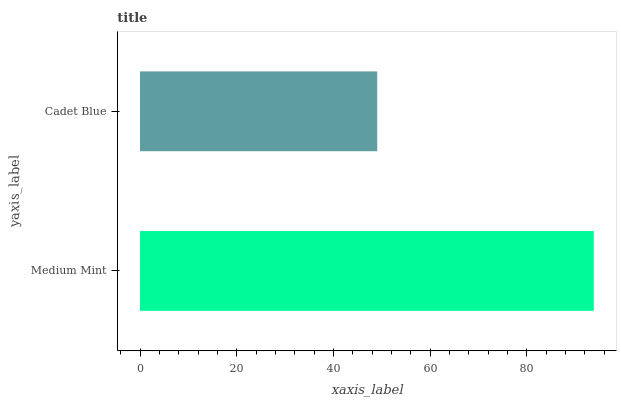Is Cadet Blue the minimum?
Answer yes or no. Yes. Is Medium Mint the maximum?
Answer yes or no. Yes. Is Cadet Blue the maximum?
Answer yes or no. No. Is Medium Mint greater than Cadet Blue?
Answer yes or no. Yes. Is Cadet Blue less than Medium Mint?
Answer yes or no. Yes. Is Cadet Blue greater than Medium Mint?
Answer yes or no. No. Is Medium Mint less than Cadet Blue?
Answer yes or no. No. Is Medium Mint the high median?
Answer yes or no. Yes. Is Cadet Blue the low median?
Answer yes or no. Yes. Is Cadet Blue the high median?
Answer yes or no. No. Is Medium Mint the low median?
Answer yes or no. No. 